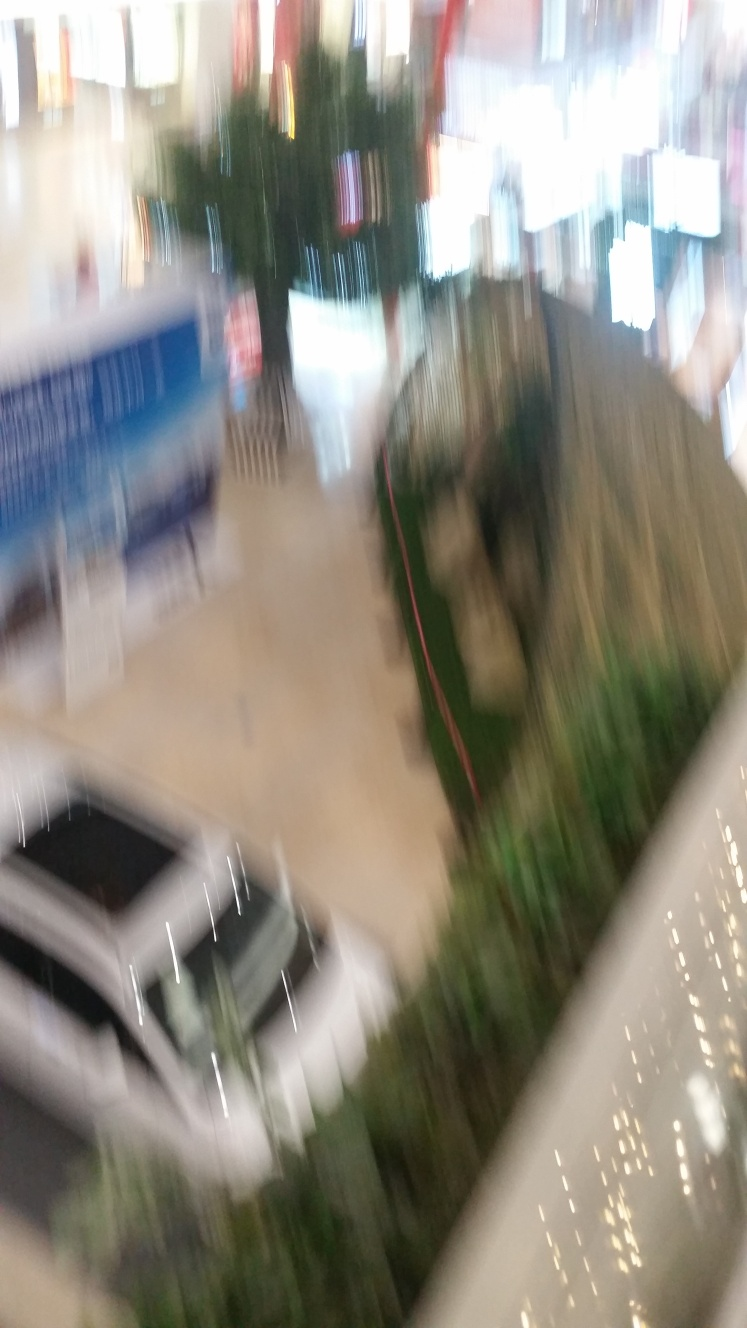Is the image of poor quality? Indeed, the image is of poor quality due to significant blurriness and lack of focus, which makes it challenging to discern fine details and diminishes the visual content's clarity. 